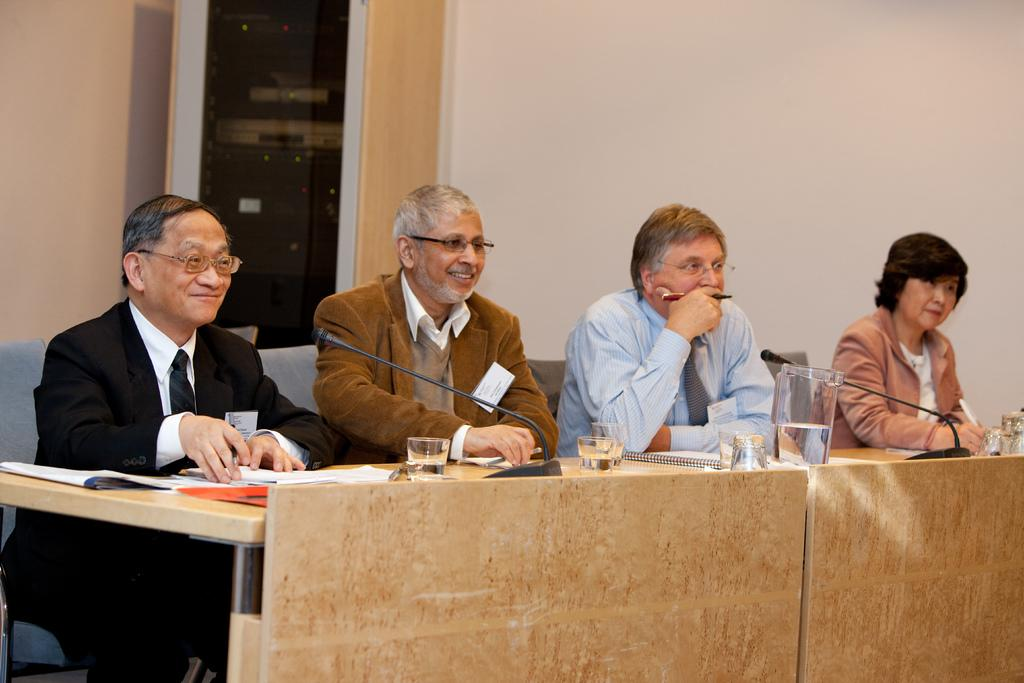How many people are seated in the image? There are four people seated in the image. What are the people sitting on? The people are seated on chairs. What is in front of the people? There is a table in front of the people. What object is on the table? A microphone is present on the table. What can be seen near the people? There are glasses visible in the image. What type of design is featured on the shade in the image? There is no shade present in the image. 